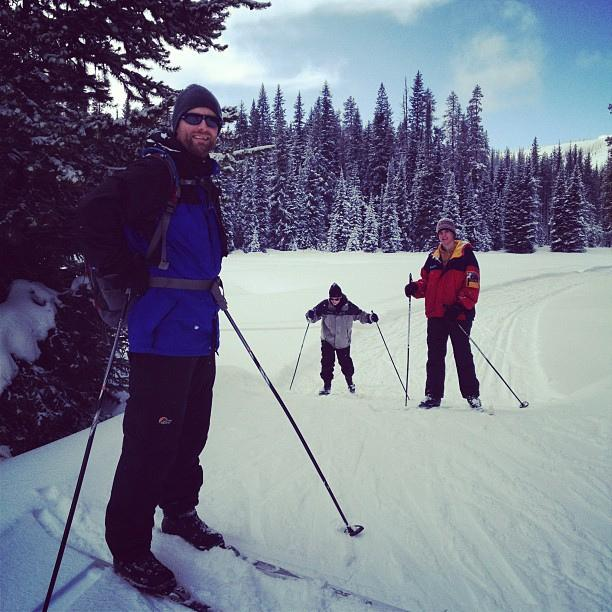Who is skiing with the man in front? two others 